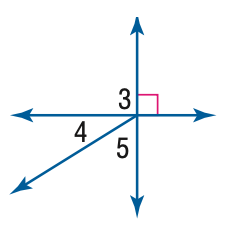Question: m \angle 4 = 32. Find the measure of \angle 5.
Choices:
A. 32
B. 58
C. 68
D. 90
Answer with the letter. Answer: B 